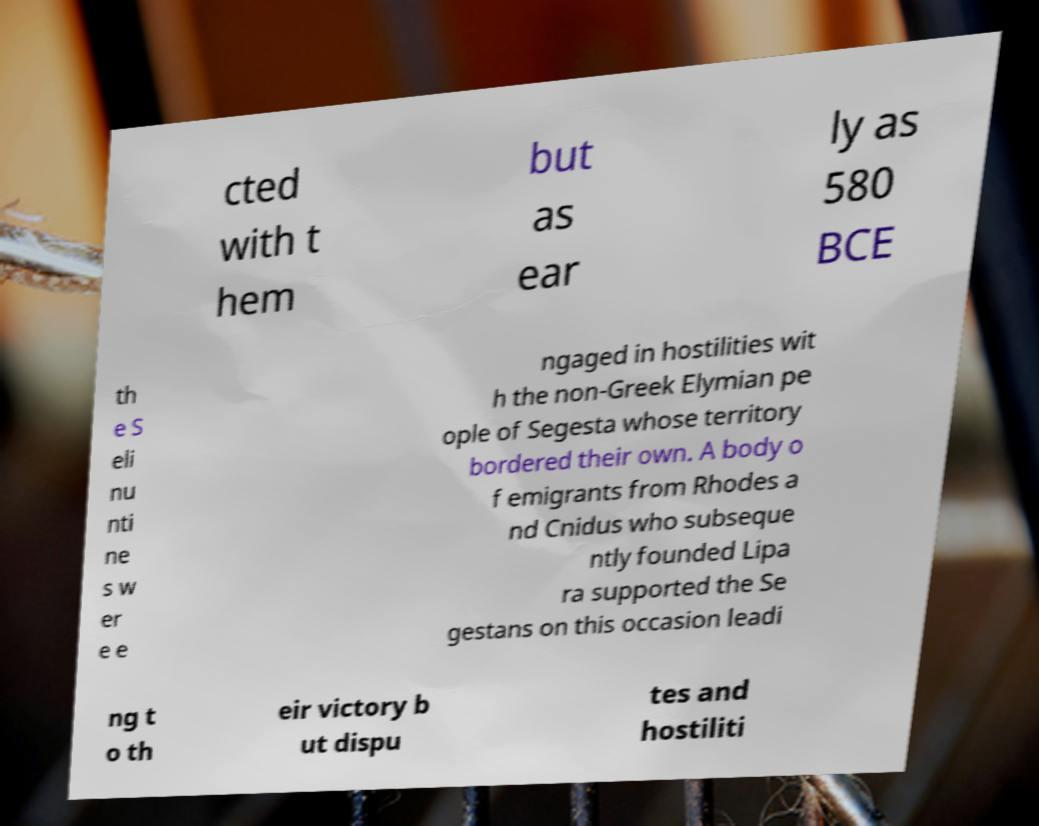Please identify and transcribe the text found in this image. cted with t hem but as ear ly as 580 BCE th e S eli nu nti ne s w er e e ngaged in hostilities wit h the non-Greek Elymian pe ople of Segesta whose territory bordered their own. A body o f emigrants from Rhodes a nd Cnidus who subseque ntly founded Lipa ra supported the Se gestans on this occasion leadi ng t o th eir victory b ut dispu tes and hostiliti 